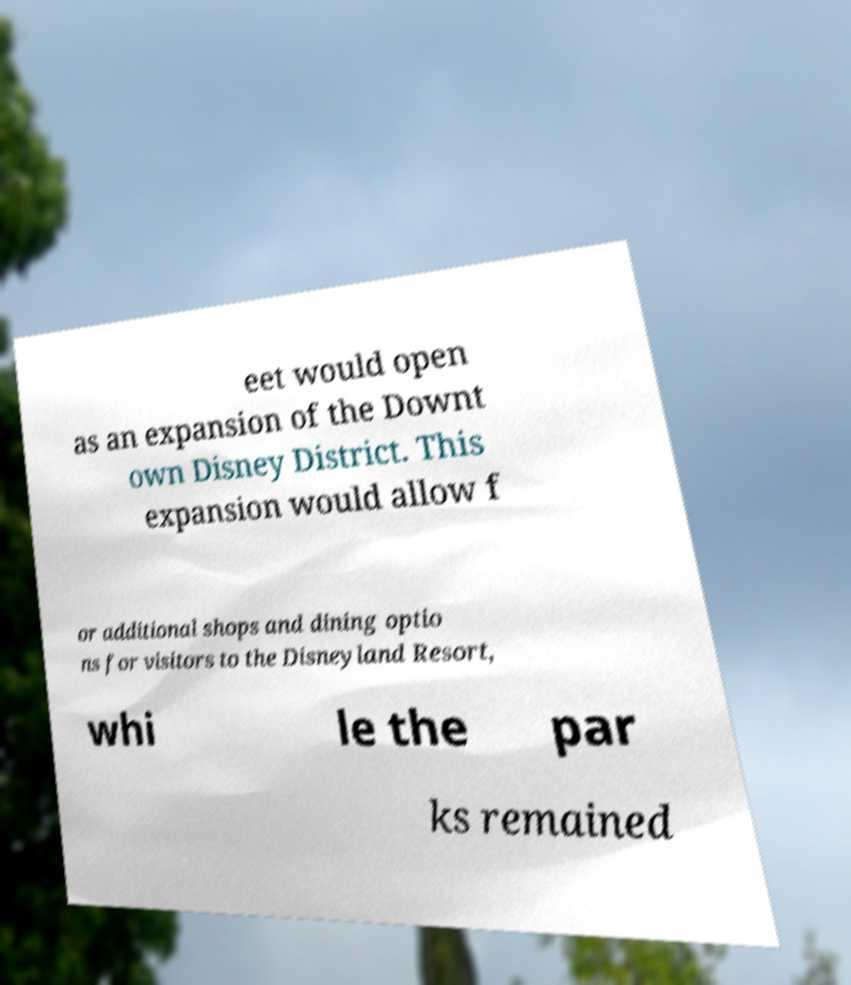Could you assist in decoding the text presented in this image and type it out clearly? eet would open as an expansion of the Downt own Disney District. This expansion would allow f or additional shops and dining optio ns for visitors to the Disneyland Resort, whi le the par ks remained 